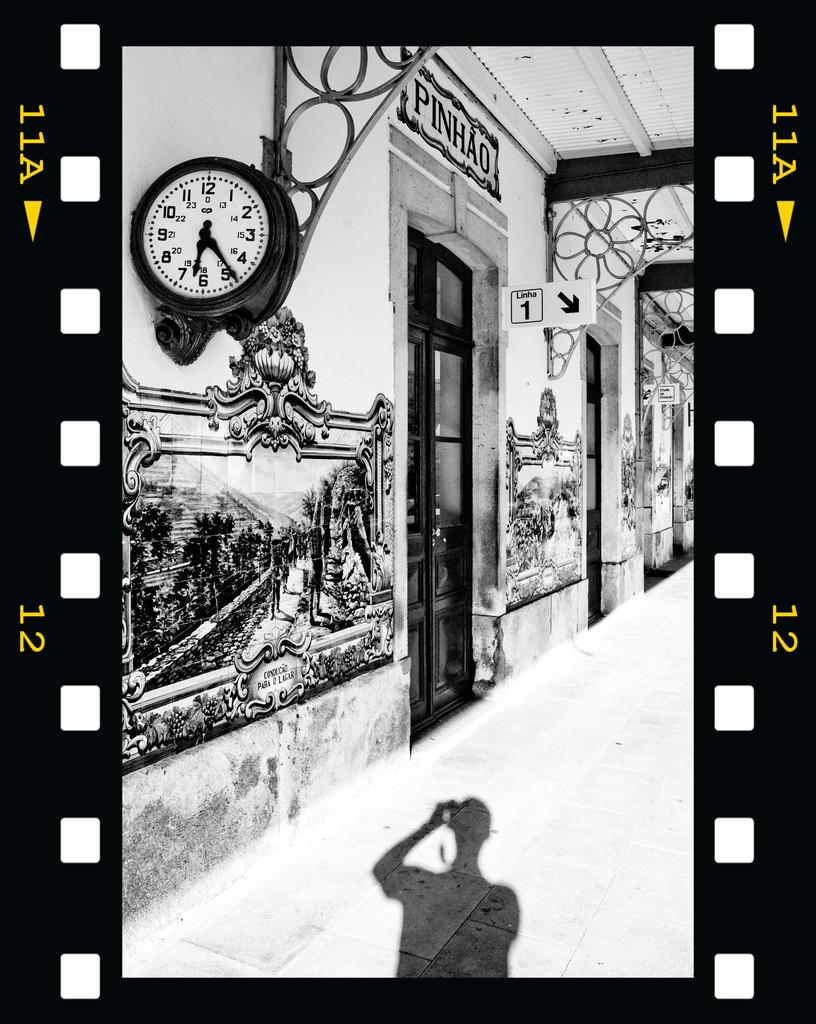<image>
Present a compact description of the photo's key features. Clock next to a building which says "PINHAO" on it. 